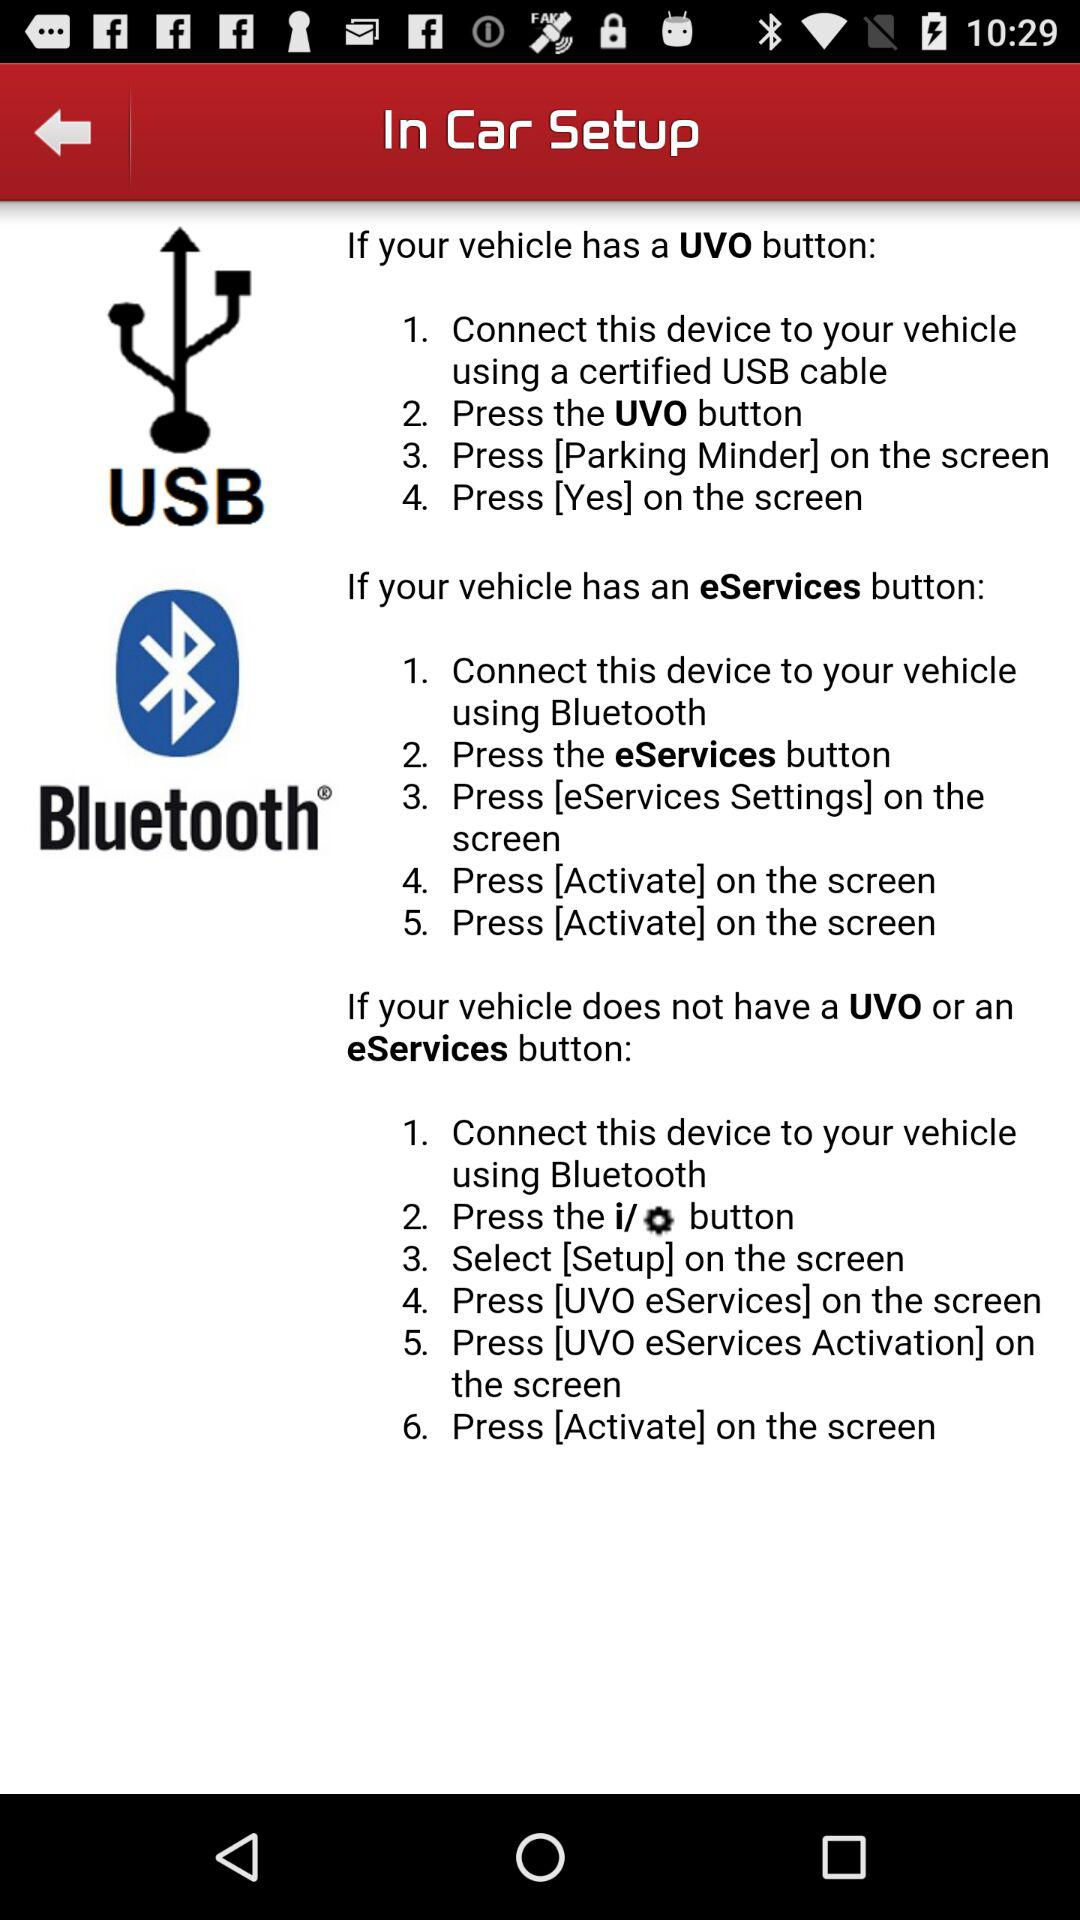How to connect if my vehicle has an eServices button? If your vehicle has an eServices button, to connect "Connect this device to your vehicle using Bluetooth", "Press the eServices button", "Press [eServices Settings] on the screen" and "Press [Activate] on the screen". 